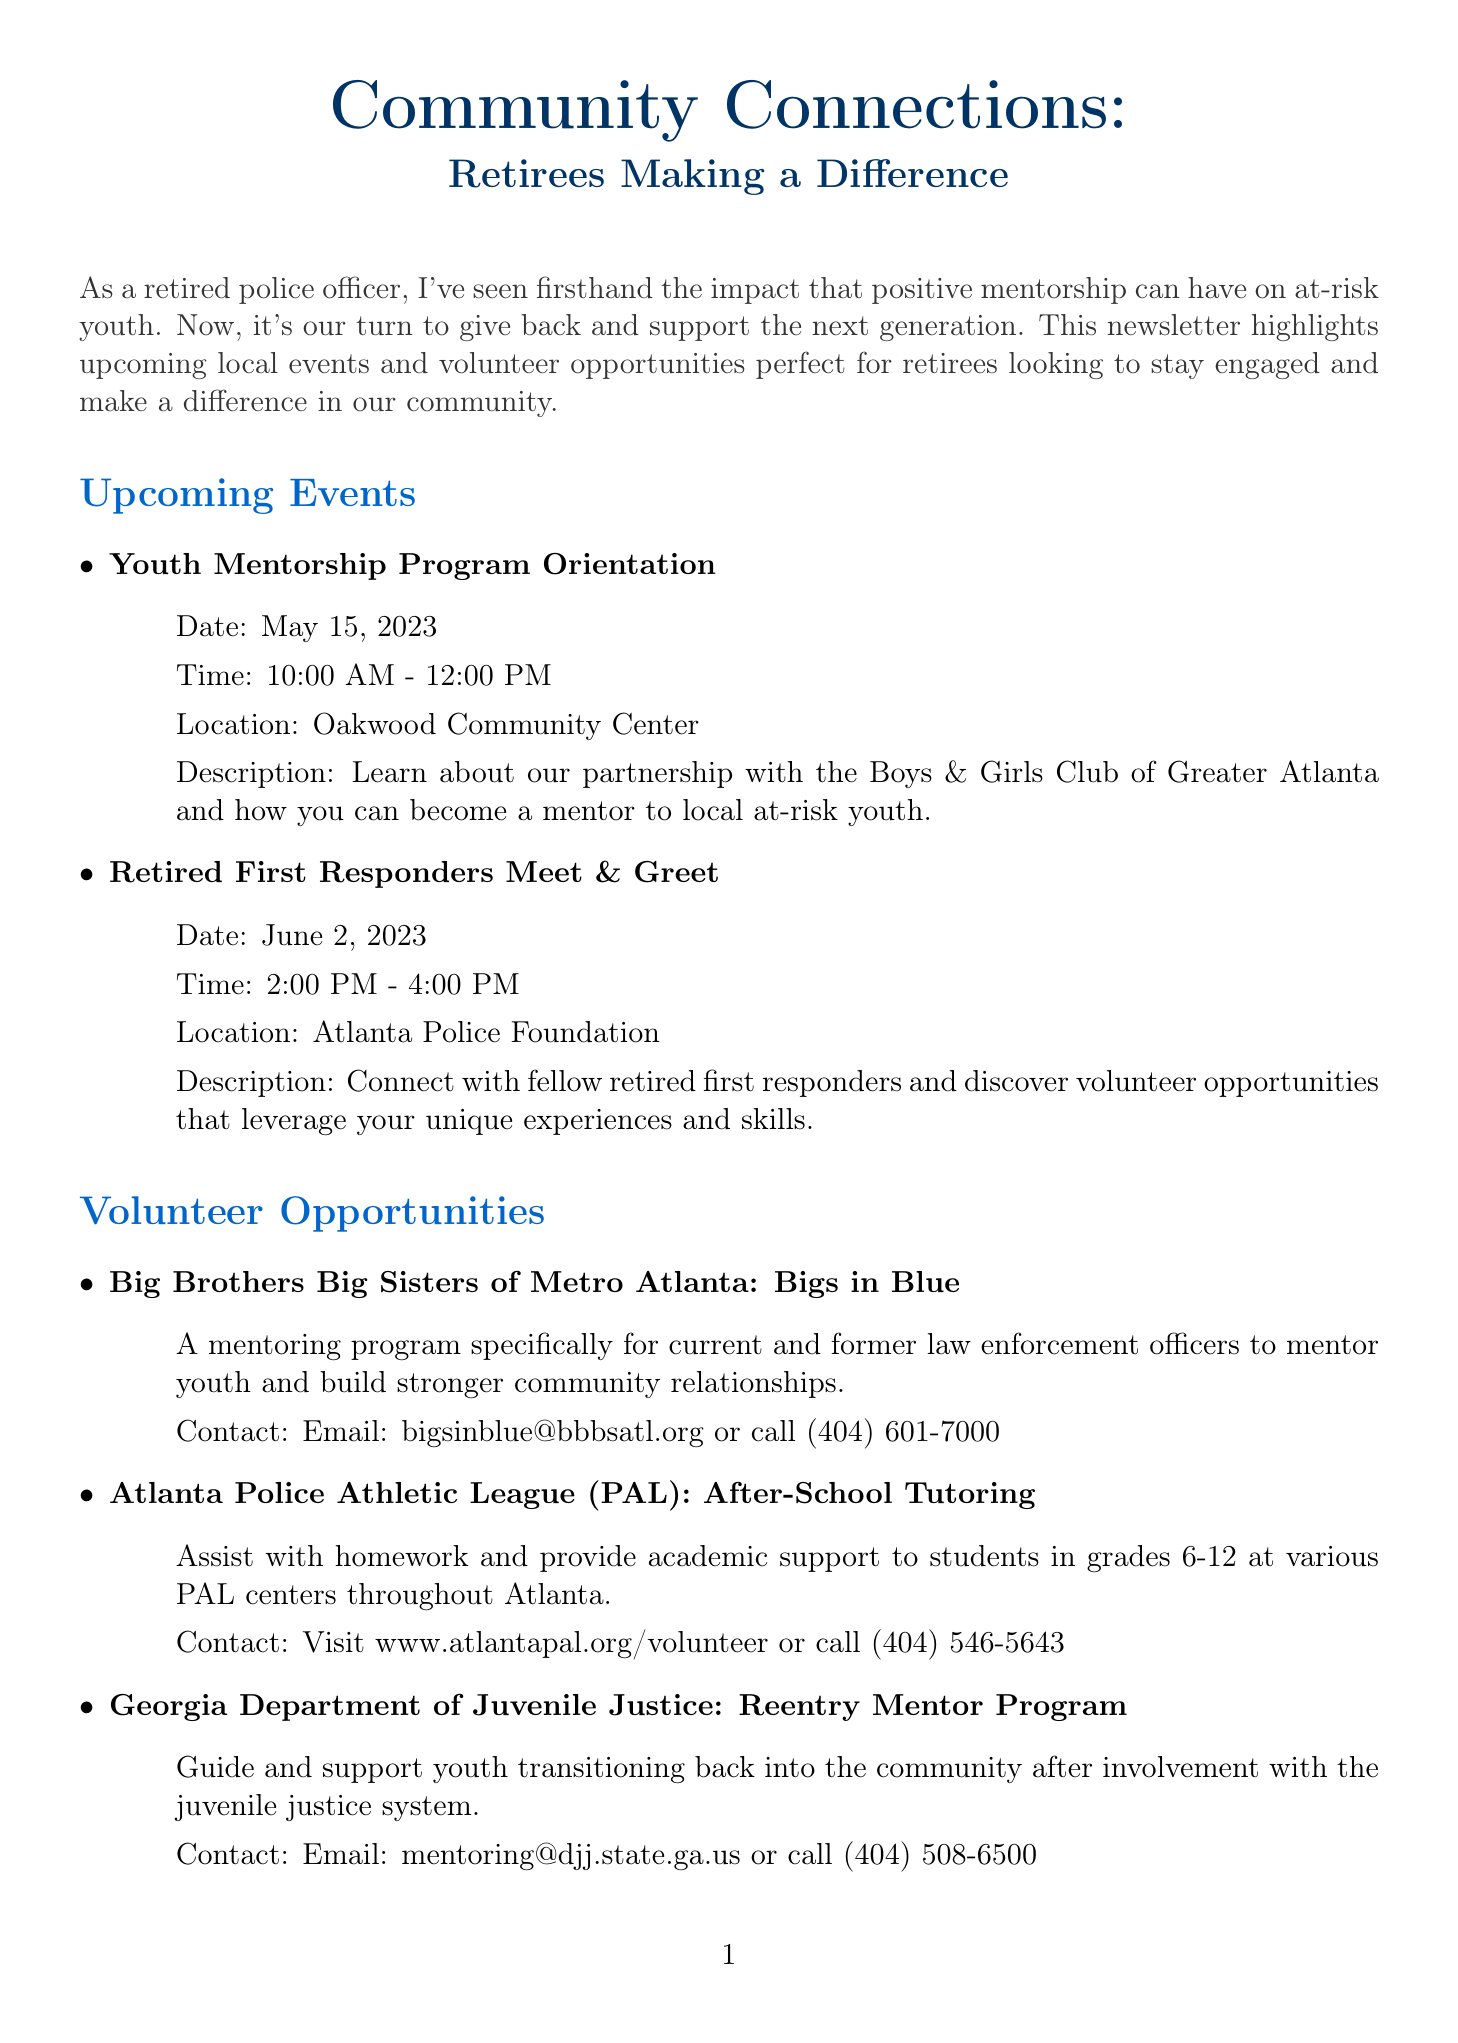What is the title of the newsletter? The title of the newsletter is provided at the beginning of the document.
Answer: Community Connections: Retirees Making a Difference When is the Youth Mentorship Program Orientation? The date of the event is stated in the upcoming events section.
Answer: May 15, 2023 Where is the Retired First Responders Meet & Greet held? The location of the event is mentioned in the upcoming events section.
Answer: Atlanta Police Foundation What organization offers the "Reentry Mentor Program"? The document lists the organization associated with this specific program.
Answer: Georgia Department of Juvenile Justice Who shares the experience in the feature story? The feature story mentions the person whose journey is highlighted.
Answer: Officer Michael Johnson What is the contact email for Big Brothers Big Sisters of Metro Atlanta? The contact information for this organization is given in the volunteer opportunities section.
Answer: bigsinblue@bbbsatl.org How many upcoming events are listed in the document? The total number of events mentioned can be counted.
Answer: 2 What mentoring program is specifically for law enforcement officers? The document names a program tailored for law enforcement officers mentoring youth.
Answer: Bigs in Blue What is the primary focus of the newsletter? The introduction paragraph summarizes the main purpose of the newsletter.
Answer: Mentor at-risk youth 